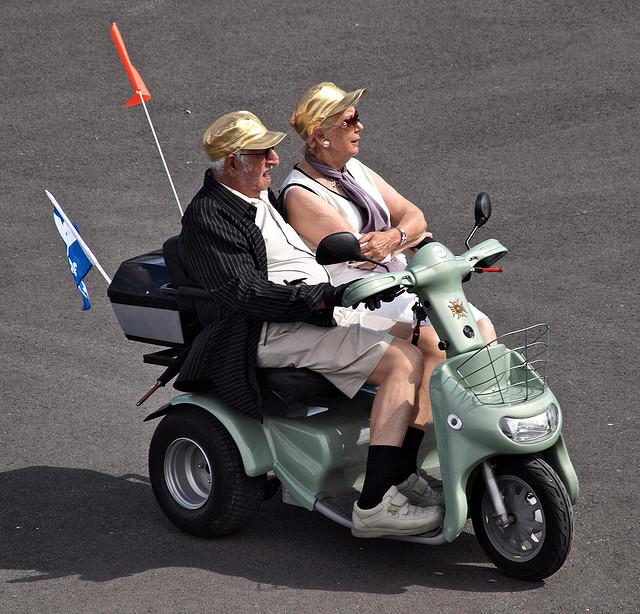Does the couple look like they are in their twenties?
Give a very brief answer. No. What country's flag is on the back of the scooter?
Write a very short answer. Unknown. Are there stripes on her dress?
Concise answer only. No. What is the couple doing?
Write a very short answer. Riding moped. Did this bike come with the basket on the back?
Quick response, please. Yes. 